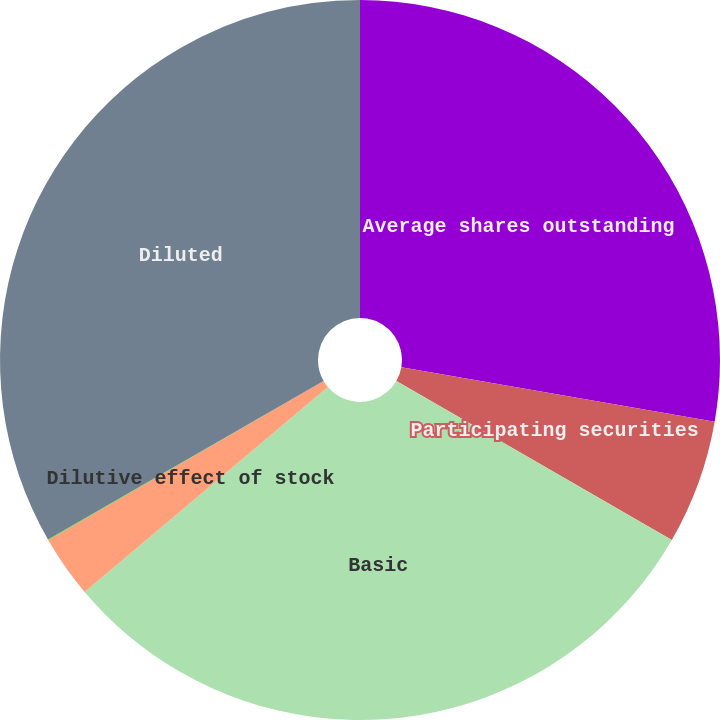<chart> <loc_0><loc_0><loc_500><loc_500><pie_chart><fcel>Average shares outstanding<fcel>Participating securities<fcel>Basic<fcel>Dilutive effect of stock<fcel>Dilutive effect of restricted<fcel>Diluted<nl><fcel>27.74%<fcel>5.59%<fcel>30.53%<fcel>2.81%<fcel>0.02%<fcel>33.31%<nl></chart> 